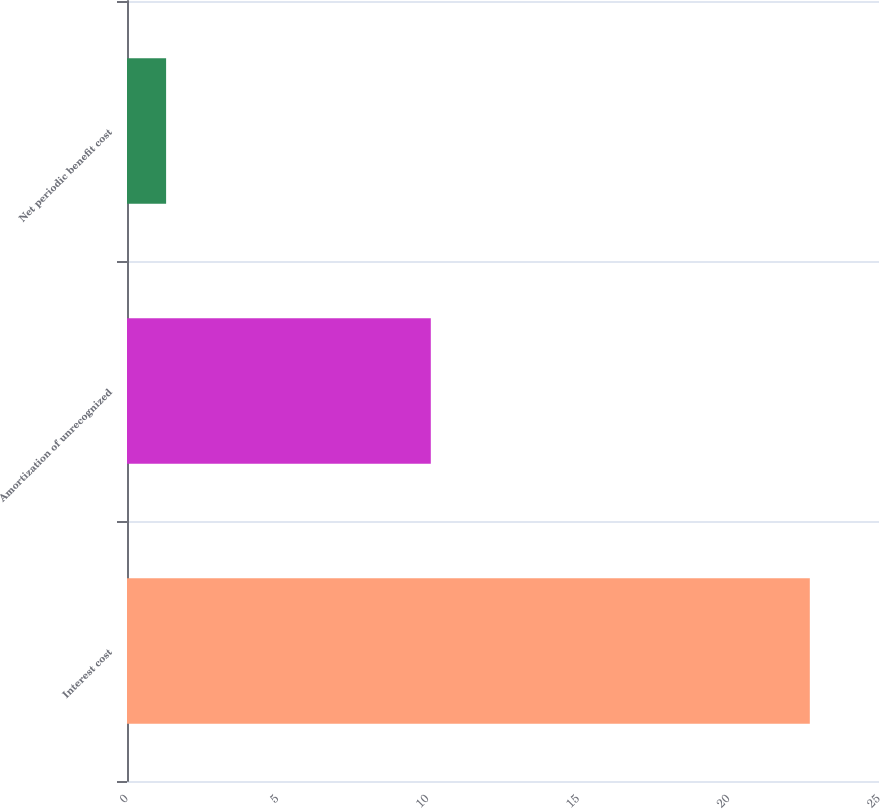<chart> <loc_0><loc_0><loc_500><loc_500><bar_chart><fcel>Interest cost<fcel>Amortization of unrecognized<fcel>Net periodic benefit cost<nl><fcel>22.7<fcel>10.1<fcel>1.3<nl></chart> 